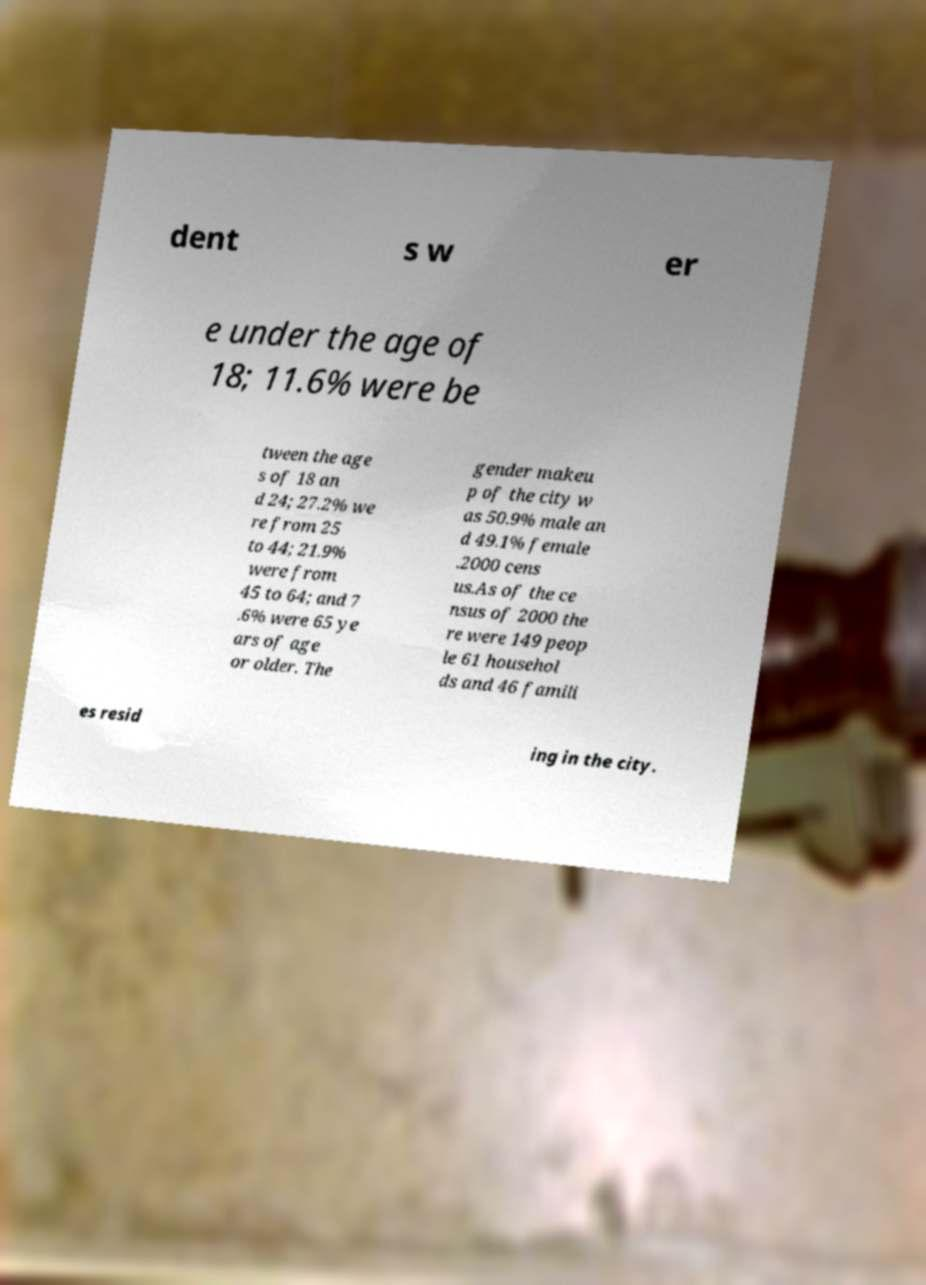Could you extract and type out the text from this image? dent s w er e under the age of 18; 11.6% were be tween the age s of 18 an d 24; 27.2% we re from 25 to 44; 21.9% were from 45 to 64; and 7 .6% were 65 ye ars of age or older. The gender makeu p of the city w as 50.9% male an d 49.1% female .2000 cens us.As of the ce nsus of 2000 the re were 149 peop le 61 househol ds and 46 famili es resid ing in the city. 